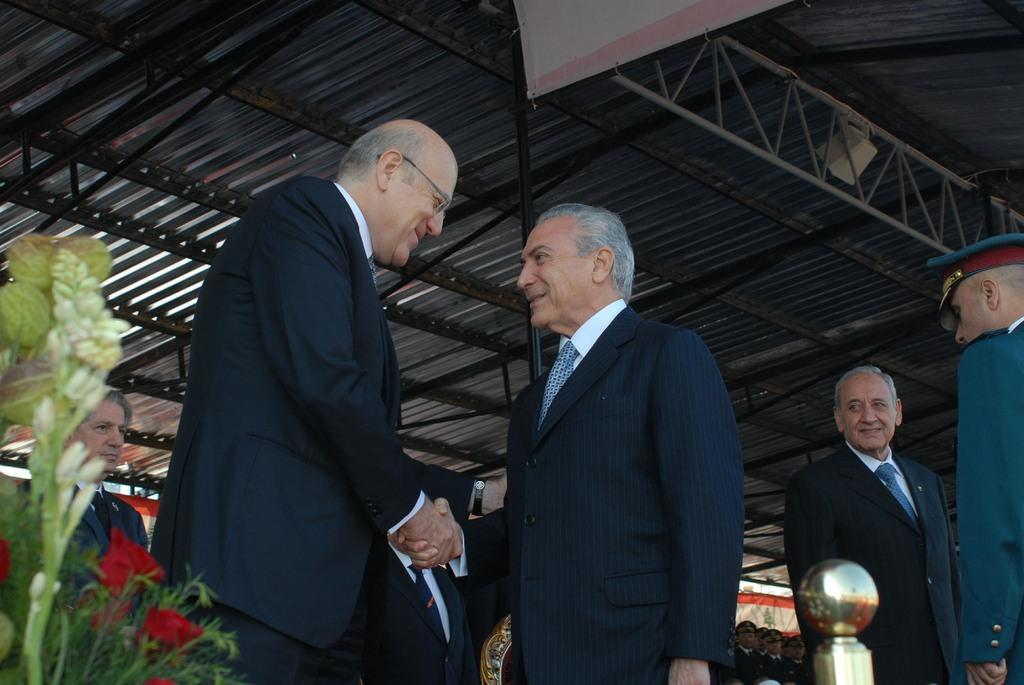How many people are in the image? There is a group of people in the image. What are two men in the image doing? Two men in the image are shaking hands and smiling. What type of plants can be seen in the image? There are flowers and leaves in the image. What structures are present in the image? There are rods and a roof in the image. What additional item can be seen in the image? There is a banner in the image. Can you describe the unspecified objects in the image? Unfortunately, the facts provided do not specify the nature of the unspecified objects in the image. Are the people in the image pushing or pulling a farm? There is no farm present in the image, nor is there any indication of the people pushing or pulling anything. 